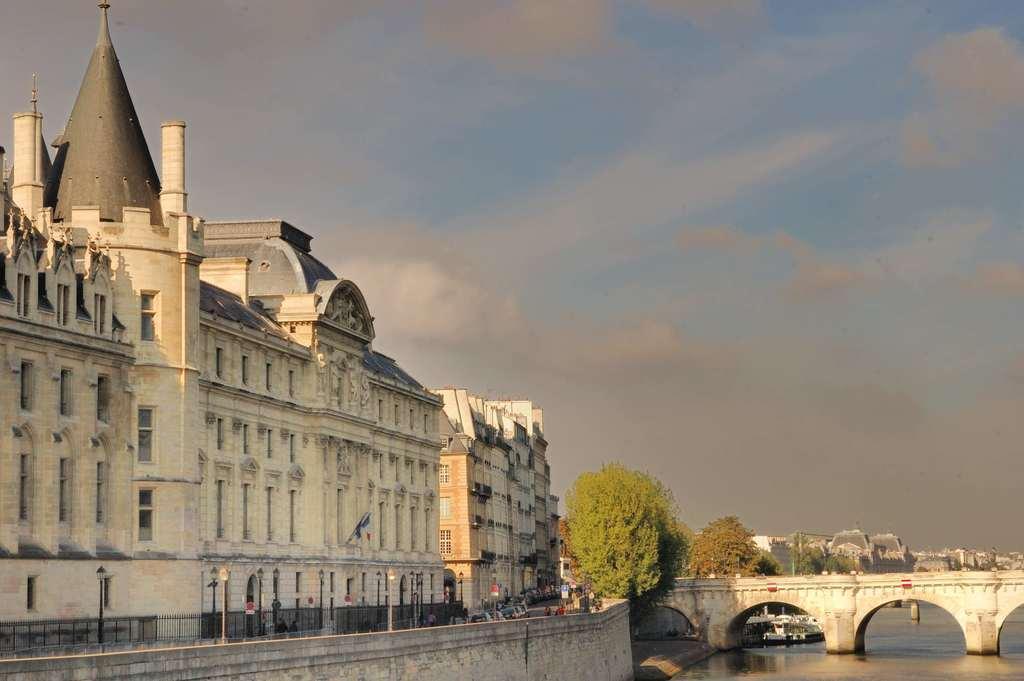Please provide a concise description of this image. In this image, we can see some buildings and there is a bridged, there are some trees, we can see water, at the top there is a sky. 